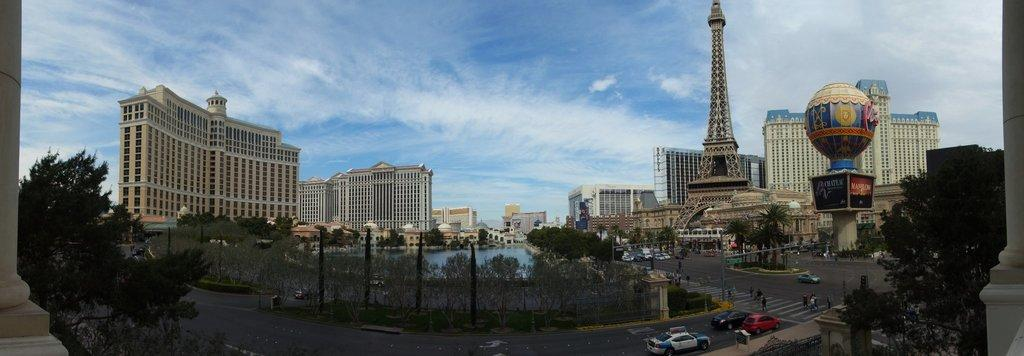What type of structures can be seen in the image? There are tall buildings in the image. Can you identify any famous landmarks in the image? Yes, the Eiffel Tower is on the right side of the image. What natural element is visible in the image? There is water visible in the image. What is happening on the road in the image? Vehicles are moving on the road in the image. What type of vegetation is present in the image? There are trees in the image. Can you see any fairies flying around the Eiffel Tower in the image? There are no fairies present in the image. How many girls are visible in the image? There is no mention of girls in the provided facts, so we cannot determine their presence in the image. 